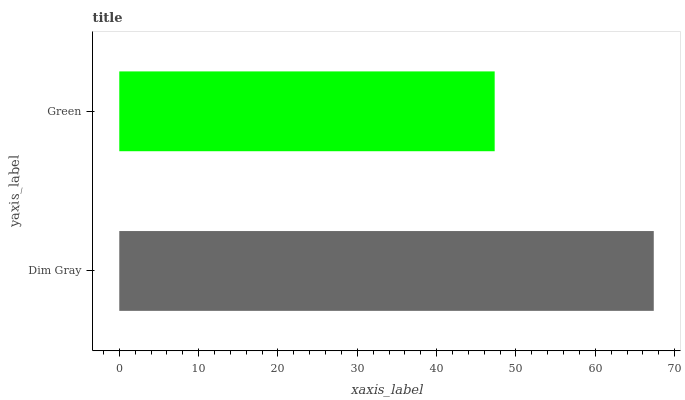Is Green the minimum?
Answer yes or no. Yes. Is Dim Gray the maximum?
Answer yes or no. Yes. Is Green the maximum?
Answer yes or no. No. Is Dim Gray greater than Green?
Answer yes or no. Yes. Is Green less than Dim Gray?
Answer yes or no. Yes. Is Green greater than Dim Gray?
Answer yes or no. No. Is Dim Gray less than Green?
Answer yes or no. No. Is Dim Gray the high median?
Answer yes or no. Yes. Is Green the low median?
Answer yes or no. Yes. Is Green the high median?
Answer yes or no. No. Is Dim Gray the low median?
Answer yes or no. No. 